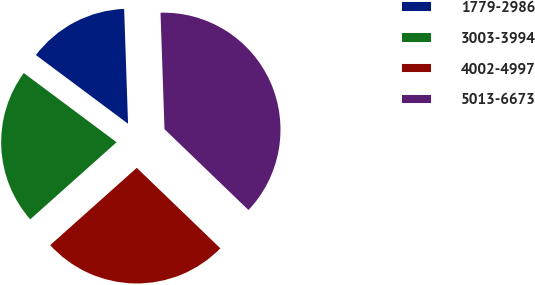Convert chart. <chart><loc_0><loc_0><loc_500><loc_500><pie_chart><fcel>1779-2986<fcel>3003-3994<fcel>4002-4997<fcel>5013-6673<nl><fcel>14.26%<fcel>21.8%<fcel>26.2%<fcel>37.74%<nl></chart> 